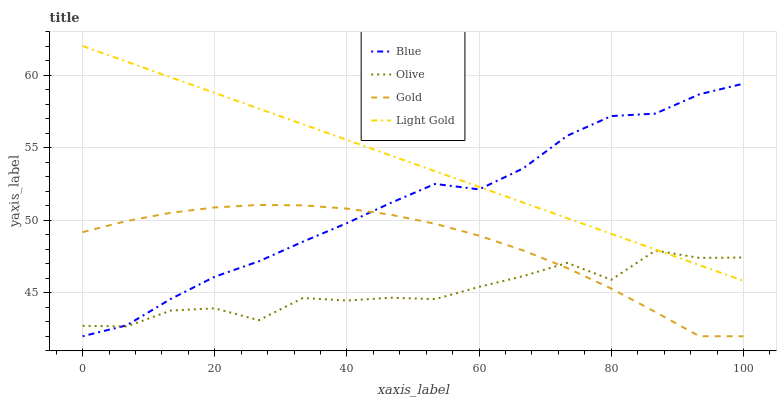Does Olive have the minimum area under the curve?
Answer yes or no. Yes. Does Light Gold have the maximum area under the curve?
Answer yes or no. Yes. Does Light Gold have the minimum area under the curve?
Answer yes or no. No. Does Olive have the maximum area under the curve?
Answer yes or no. No. Is Light Gold the smoothest?
Answer yes or no. Yes. Is Olive the roughest?
Answer yes or no. Yes. Is Olive the smoothest?
Answer yes or no. No. Is Light Gold the roughest?
Answer yes or no. No. Does Blue have the lowest value?
Answer yes or no. Yes. Does Olive have the lowest value?
Answer yes or no. No. Does Light Gold have the highest value?
Answer yes or no. Yes. Does Olive have the highest value?
Answer yes or no. No. Is Gold less than Light Gold?
Answer yes or no. Yes. Is Light Gold greater than Gold?
Answer yes or no. Yes. Does Blue intersect Light Gold?
Answer yes or no. Yes. Is Blue less than Light Gold?
Answer yes or no. No. Is Blue greater than Light Gold?
Answer yes or no. No. Does Gold intersect Light Gold?
Answer yes or no. No. 